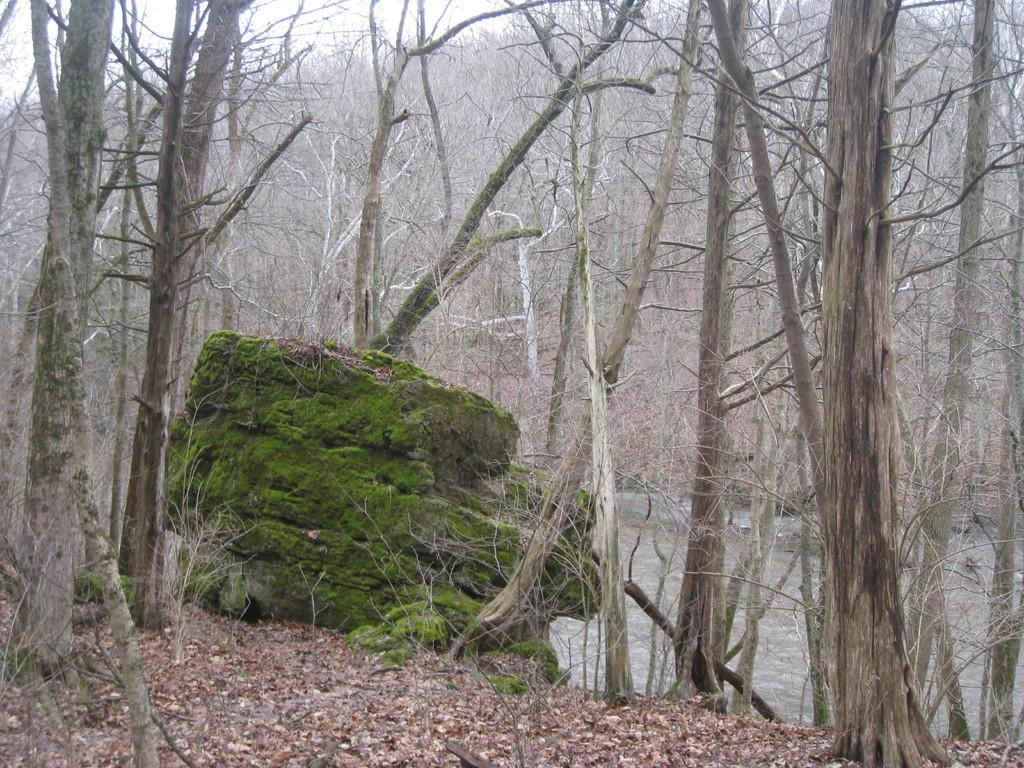What type of vegetation can be seen in the image? There are trees in the image. What can be seen in the background of the image? The sky is visible in the background of the image. What is at the bottom of the image? There is water at the bottom of the image. Are there any specific features of the trees visible in the image? Leaves are present in the image. Can you tell me how many people are talking near the trees in the image? There is no mention of people or talking in the image; it only features trees, the sky, water, and leaves. What type of hair can be seen on the trees in the image? There is no hair present in the image; it only features trees, the sky, water, and leaves. 